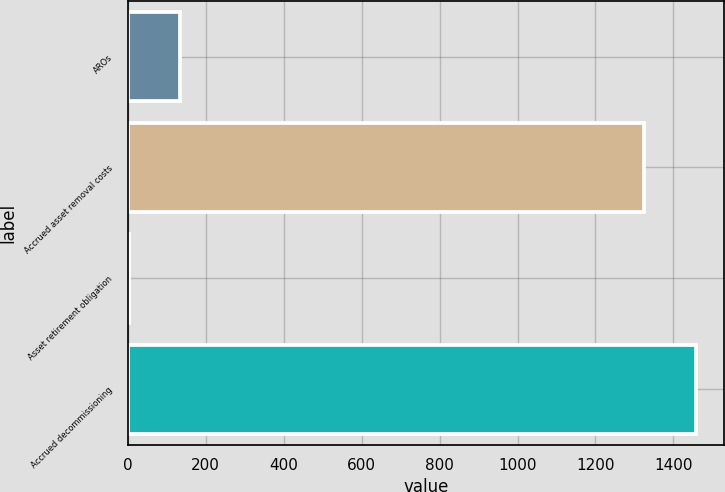Convert chart to OTSL. <chart><loc_0><loc_0><loc_500><loc_500><bar_chart><fcel>AROs<fcel>Accrued asset removal costs<fcel>Asset retirement obligation<fcel>Accrued decommissioning<nl><fcel>134.6<fcel>1325<fcel>2<fcel>1457.6<nl></chart> 